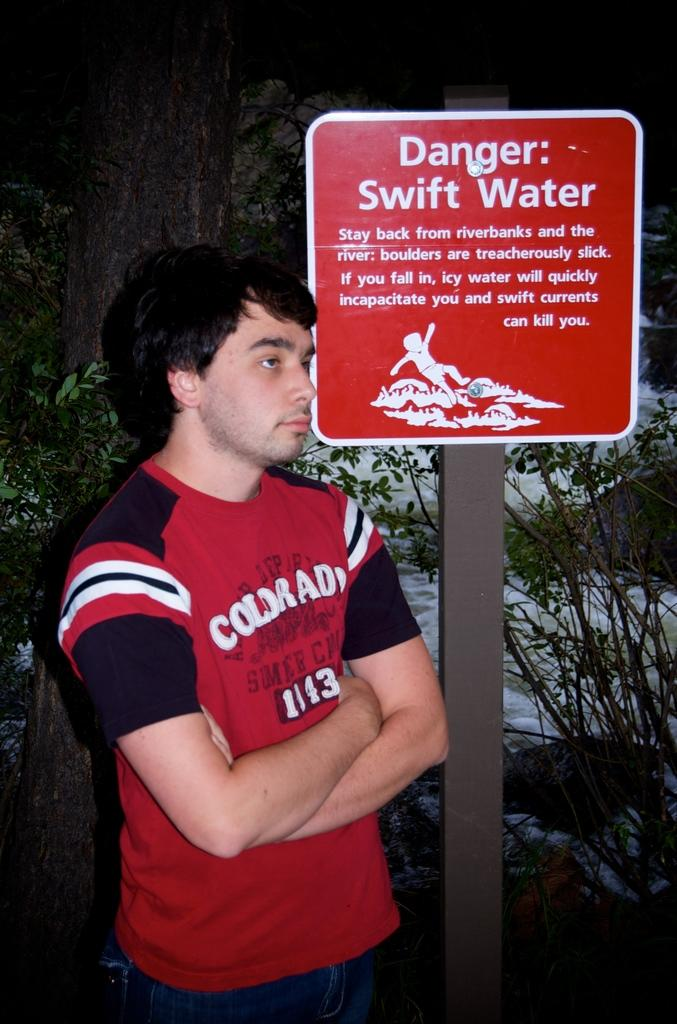Provide a one-sentence caption for the provided image. man in a red shirt standing under a danger street sign. 